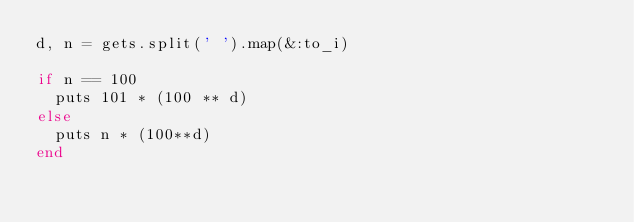Convert code to text. <code><loc_0><loc_0><loc_500><loc_500><_Ruby_>d, n = gets.split(' ').map(&:to_i)
 
if n == 100
  puts 101 * (100 ** d)
else
  puts n * (100**d)
end</code> 